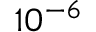<formula> <loc_0><loc_0><loc_500><loc_500>1 0 ^ { - 6 }</formula> 